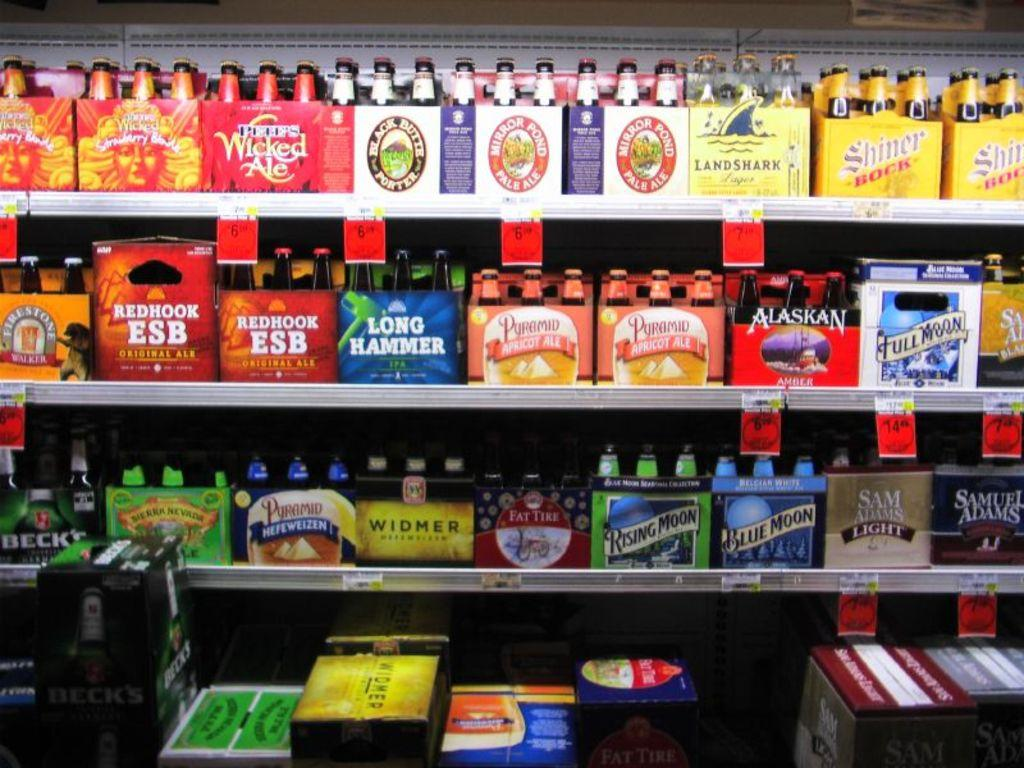<image>
Create a compact narrative representing the image presented. Rows of bottled beverages including Long Hammer and Redhook ESB. 